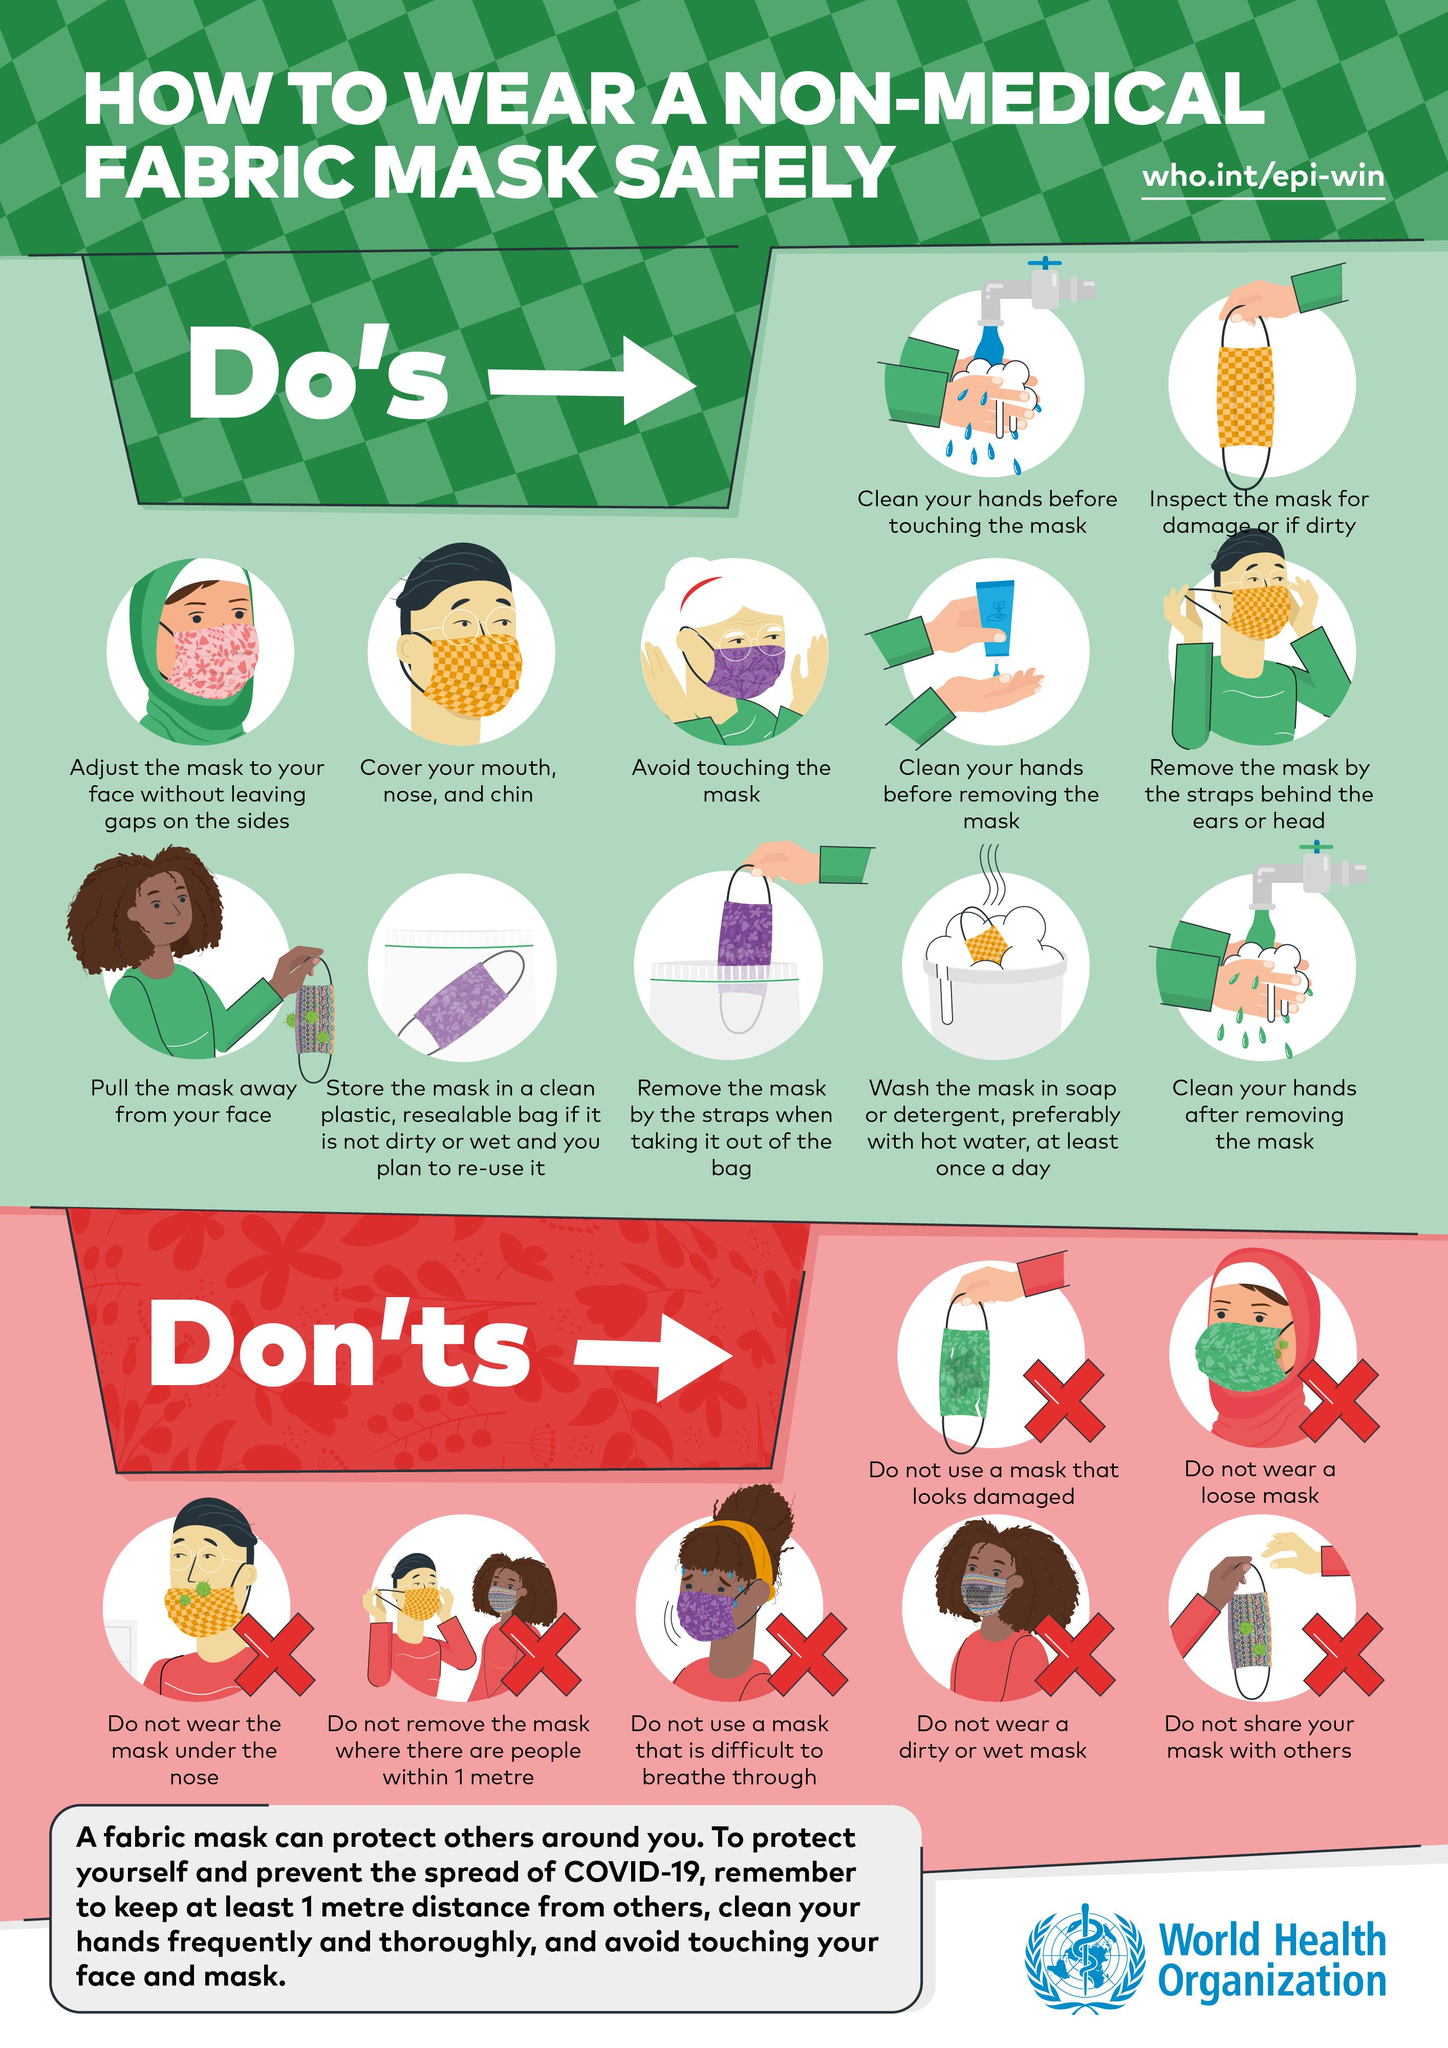Outline some significant characteristics in this image. It is not advisable to wear a loose mask. The background color of all "Don'ts" is yellow, green, red, or black. It is advisable to clean your hands after removing the mask. The background color for all "dos" is green, regardless of whether they are red, green, yellow, or orange. It is crucial to thoroughly check a mask for any damage or dirt before wearing it to prevent potential harm or contamination. 